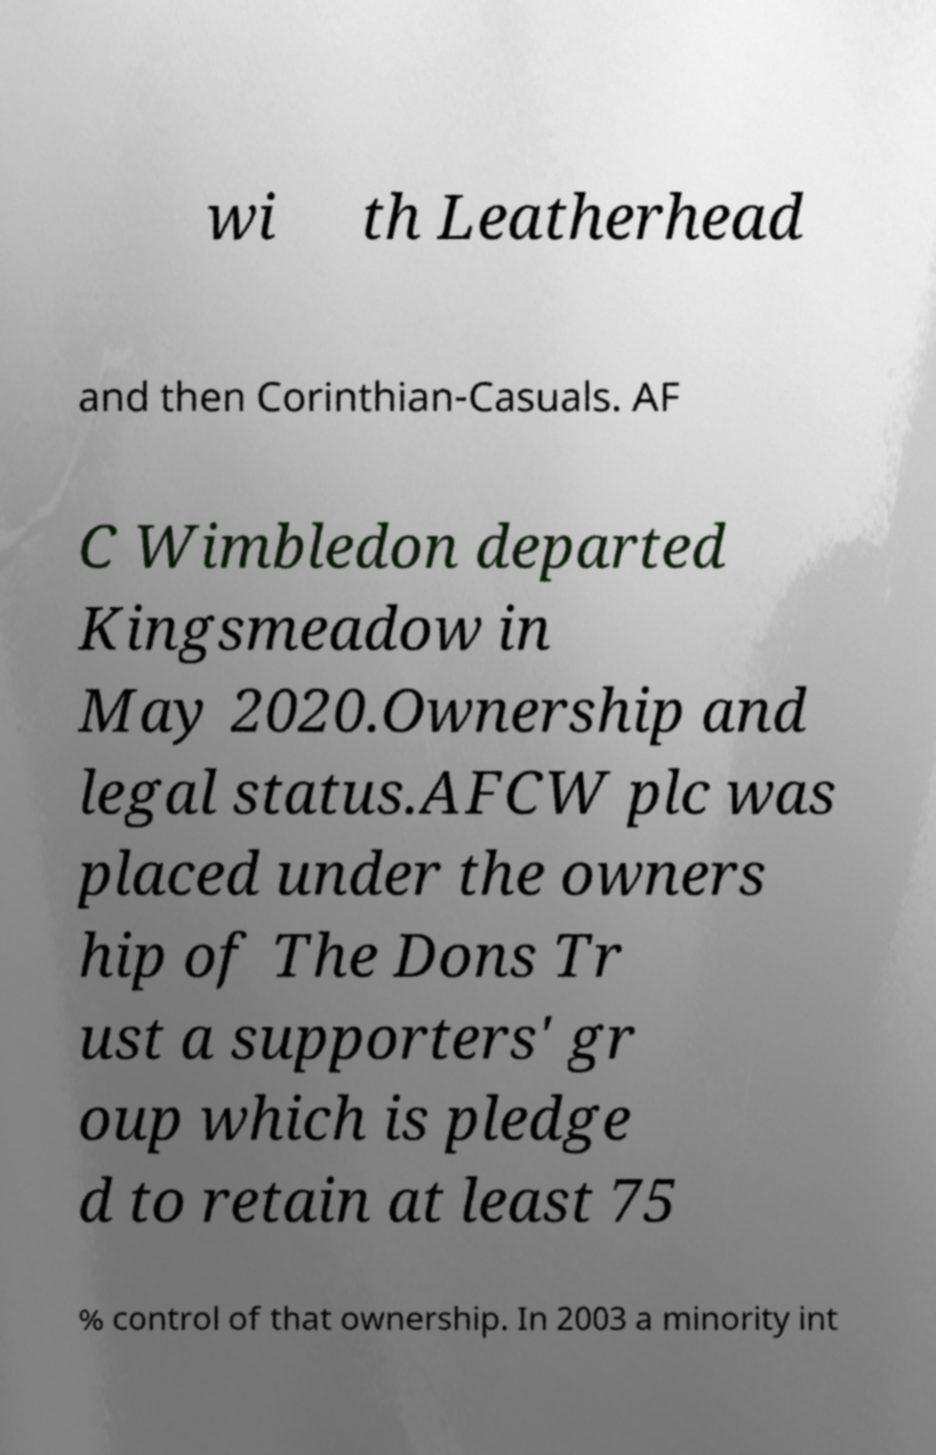Please read and relay the text visible in this image. What does it say? wi th Leatherhead and then Corinthian-Casuals. AF C Wimbledon departed Kingsmeadow in May 2020.Ownership and legal status.AFCW plc was placed under the owners hip of The Dons Tr ust a supporters' gr oup which is pledge d to retain at least 75 % control of that ownership. In 2003 a minority int 